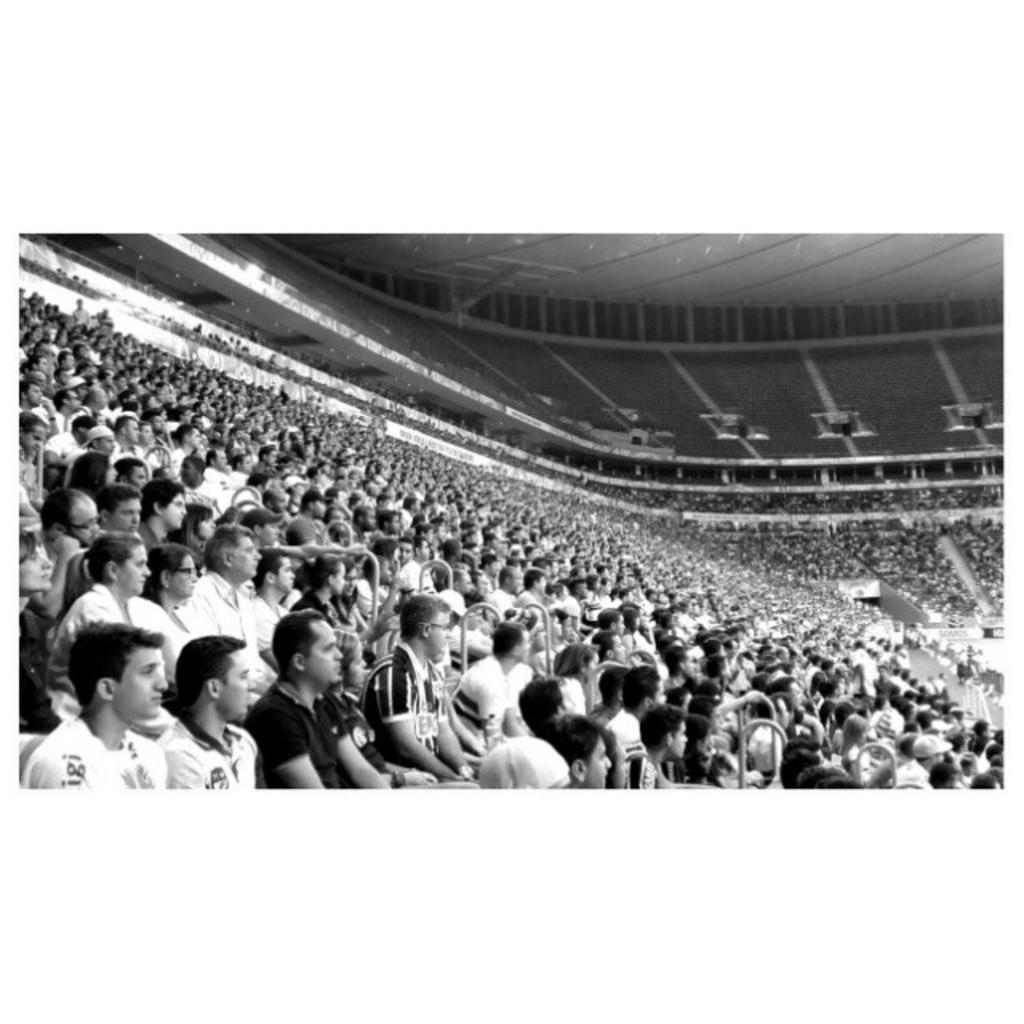What is the color scheme of the image? The image is black and white. What type of signage can be seen in the image? There are hoardings in the image. What part of the room is visible in the image? The ceiling is visible in the image. What are the people in the image doing? There is a group of people sitting on chairs in the image. What type of ornament is hanging from the ceiling in the image? There is no ornament hanging from the ceiling in the image. Can you tell me how many hats are being worn by the people in the image? There is no information about hats being worn by the people in the image. 